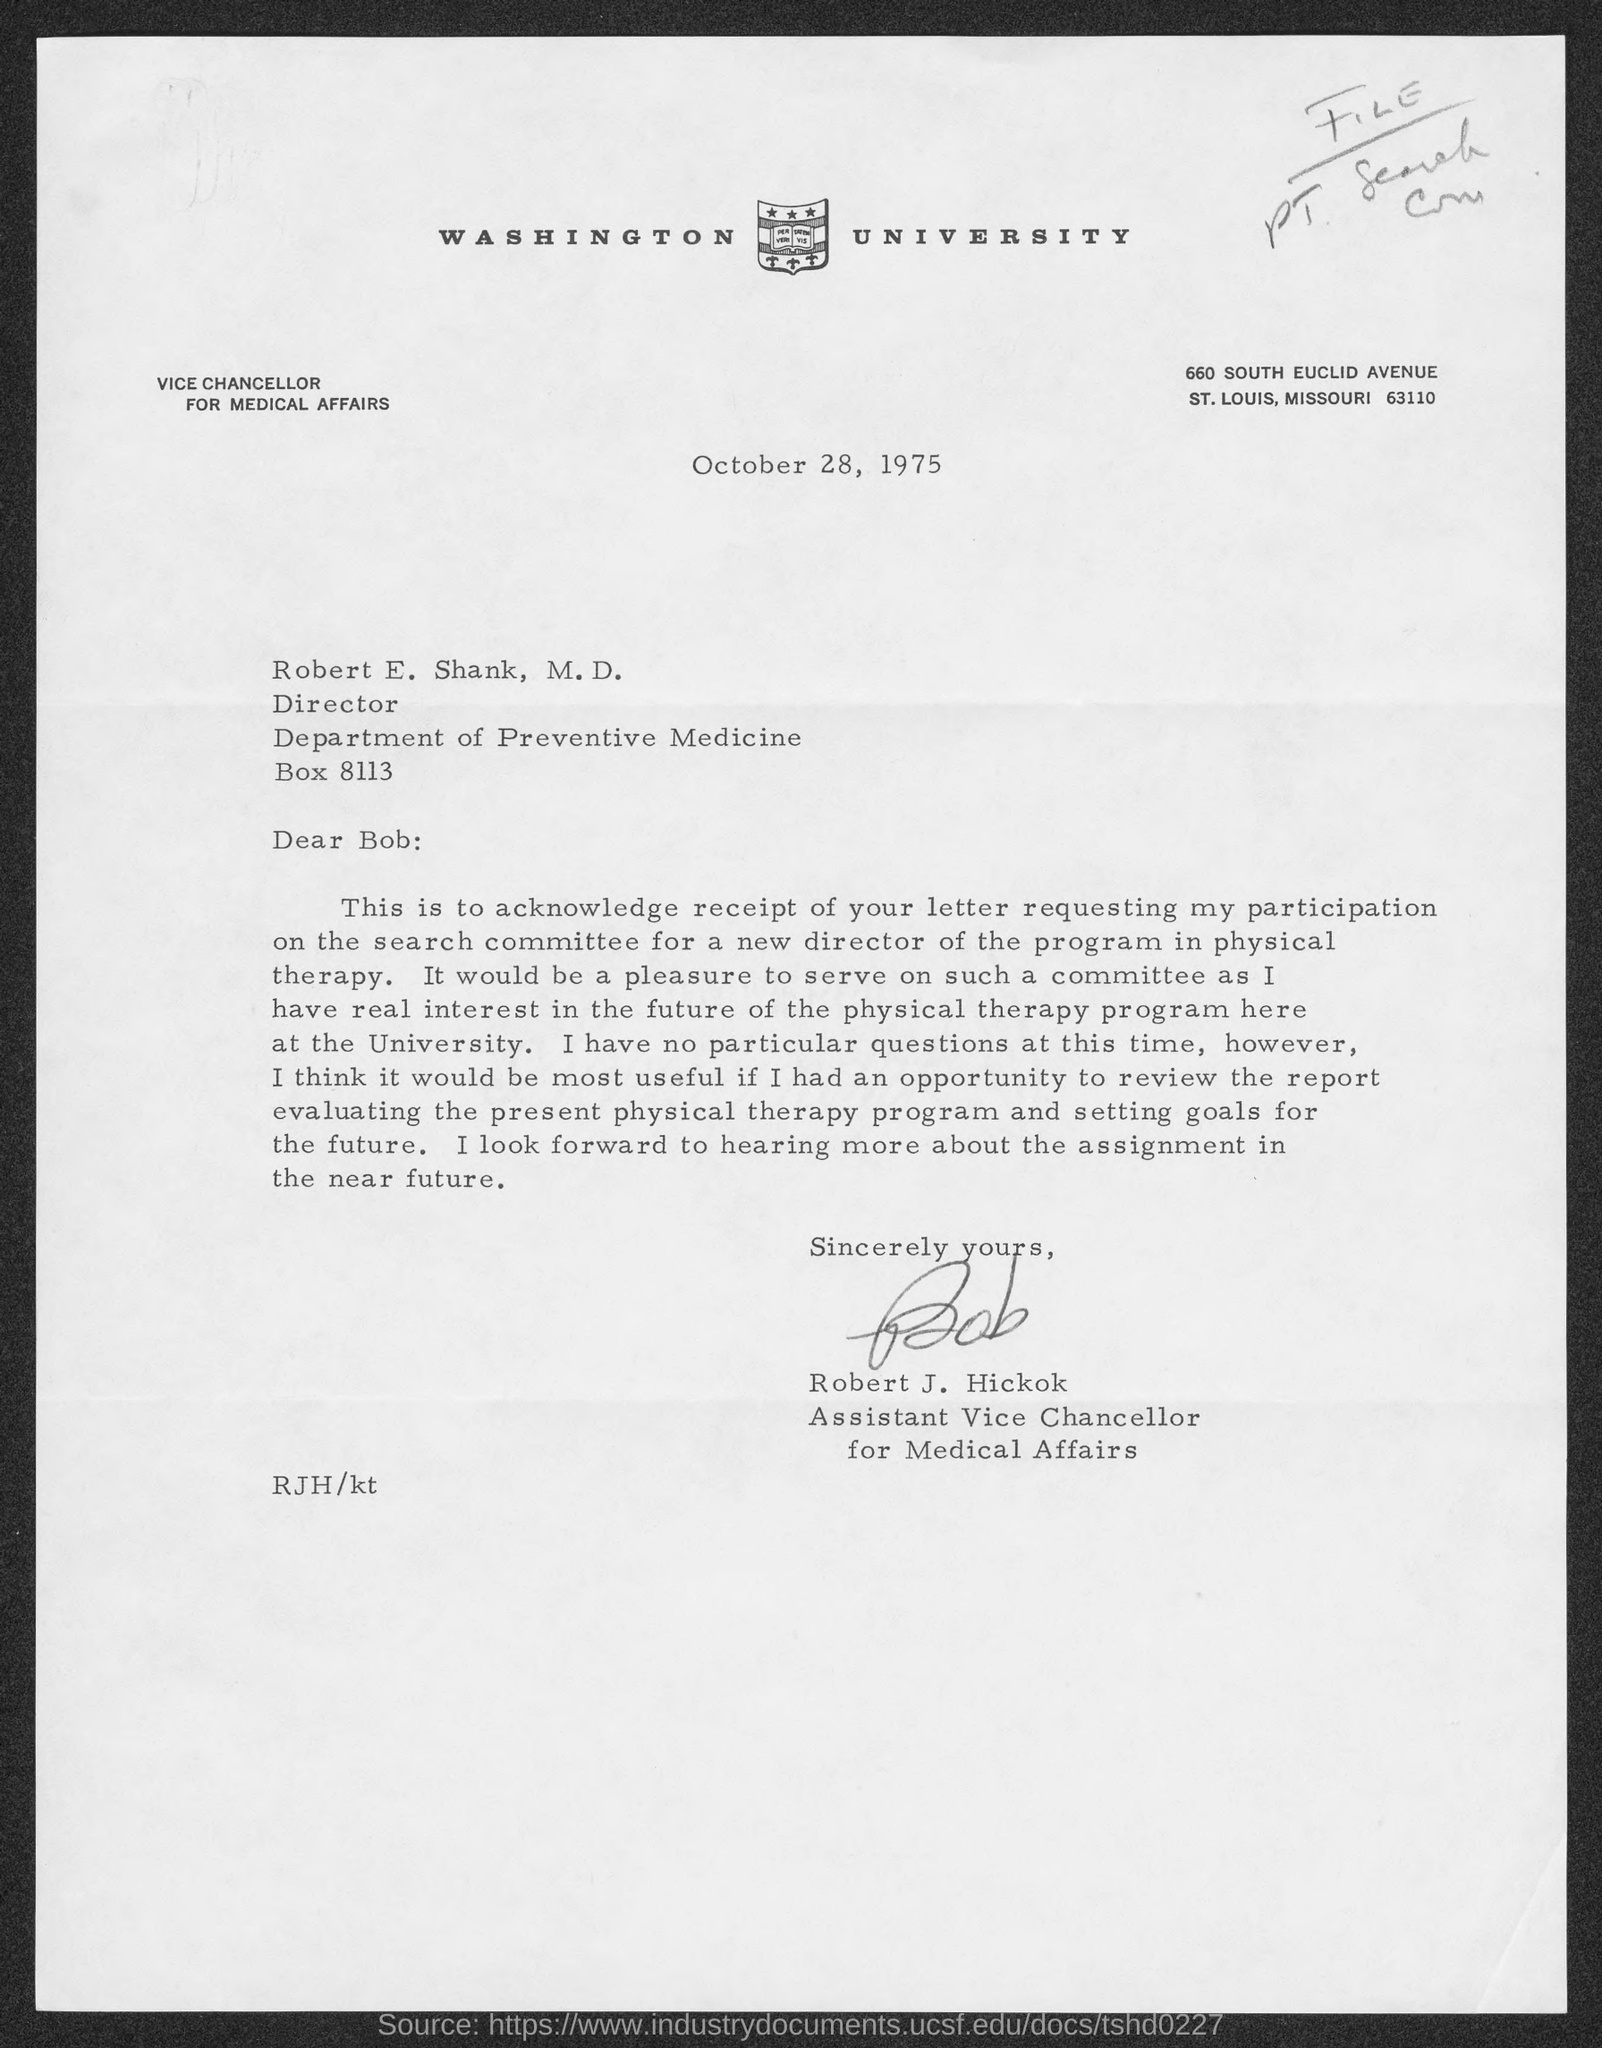Highlight a few significant elements in this photo. The salutation of the letter is "Dear Bob: The date is October 28, 1975. 